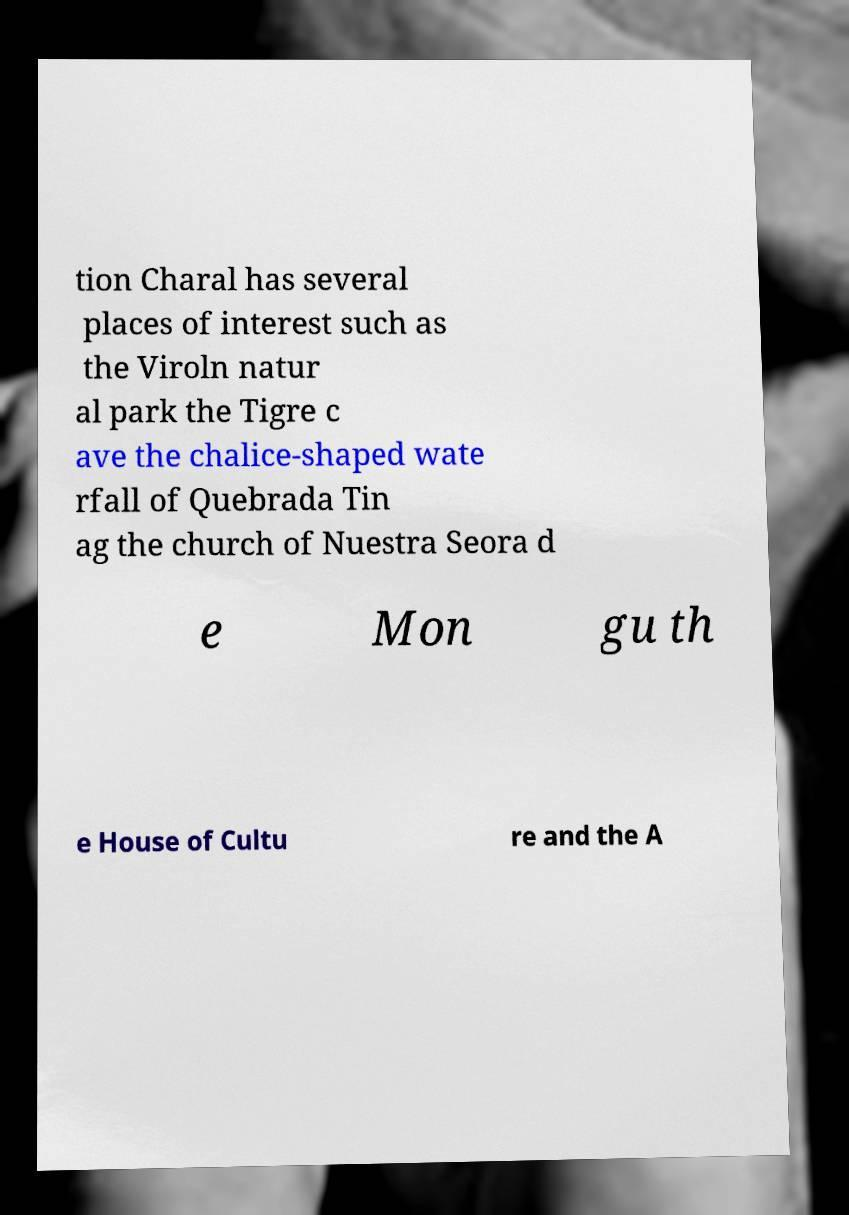Please identify and transcribe the text found in this image. tion Charal has several places of interest such as the Viroln natur al park the Tigre c ave the chalice-shaped wate rfall of Quebrada Tin ag the church of Nuestra Seora d e Mon gu th e House of Cultu re and the A 